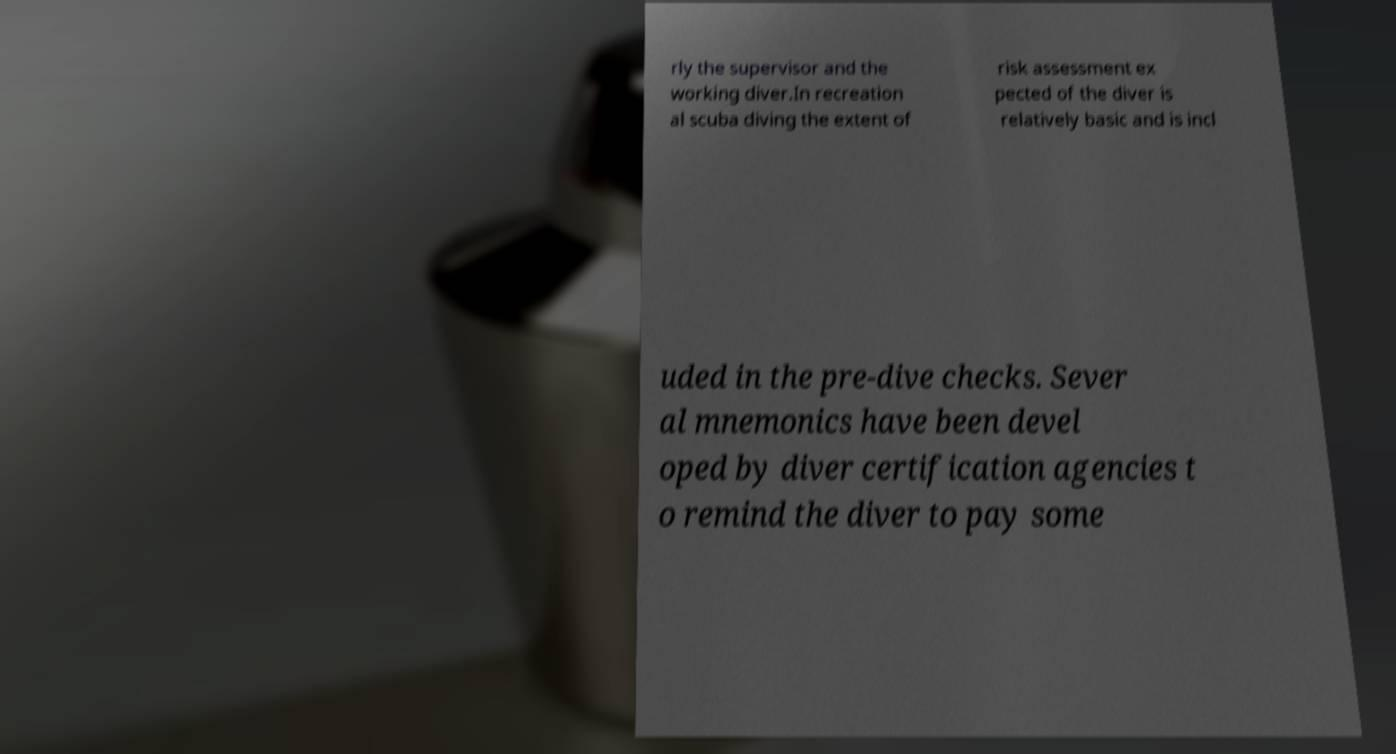Could you assist in decoding the text presented in this image and type it out clearly? rly the supervisor and the working diver.In recreation al scuba diving the extent of risk assessment ex pected of the diver is relatively basic and is incl uded in the pre-dive checks. Sever al mnemonics have been devel oped by diver certification agencies t o remind the diver to pay some 